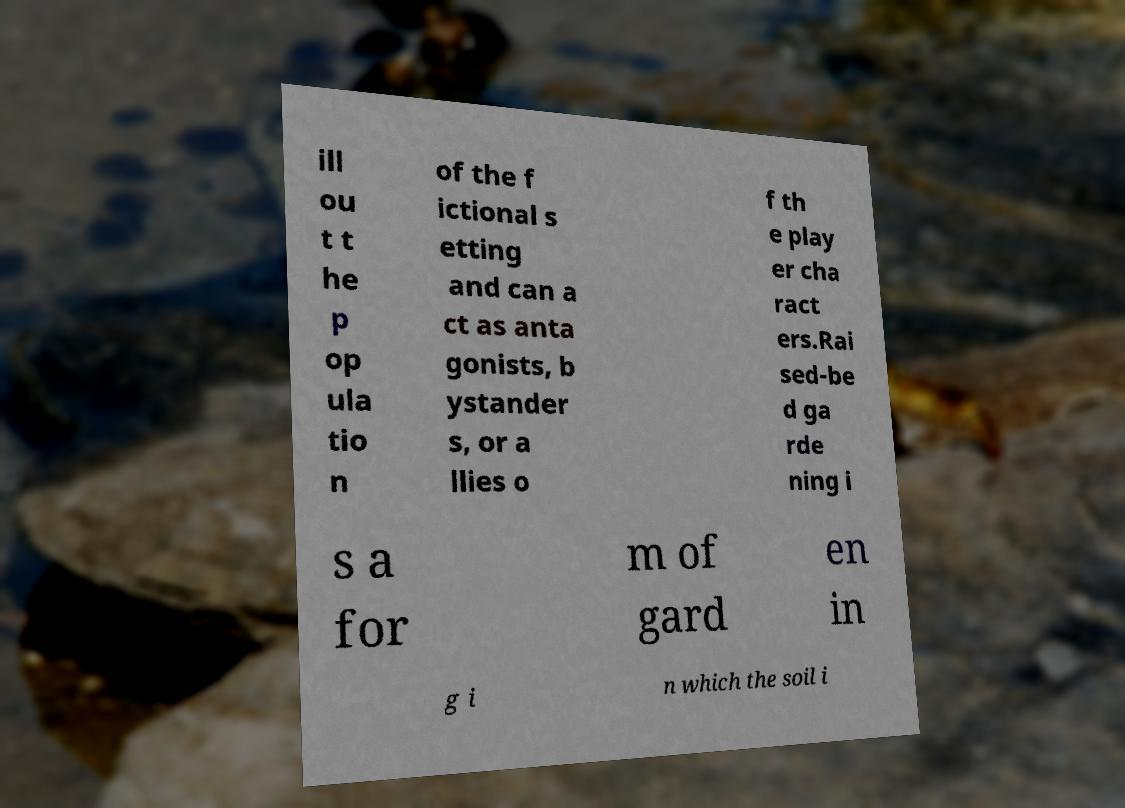What messages or text are displayed in this image? I need them in a readable, typed format. ill ou t t he p op ula tio n of the f ictional s etting and can a ct as anta gonists, b ystander s, or a llies o f th e play er cha ract ers.Rai sed-be d ga rde ning i s a for m of gard en in g i n which the soil i 